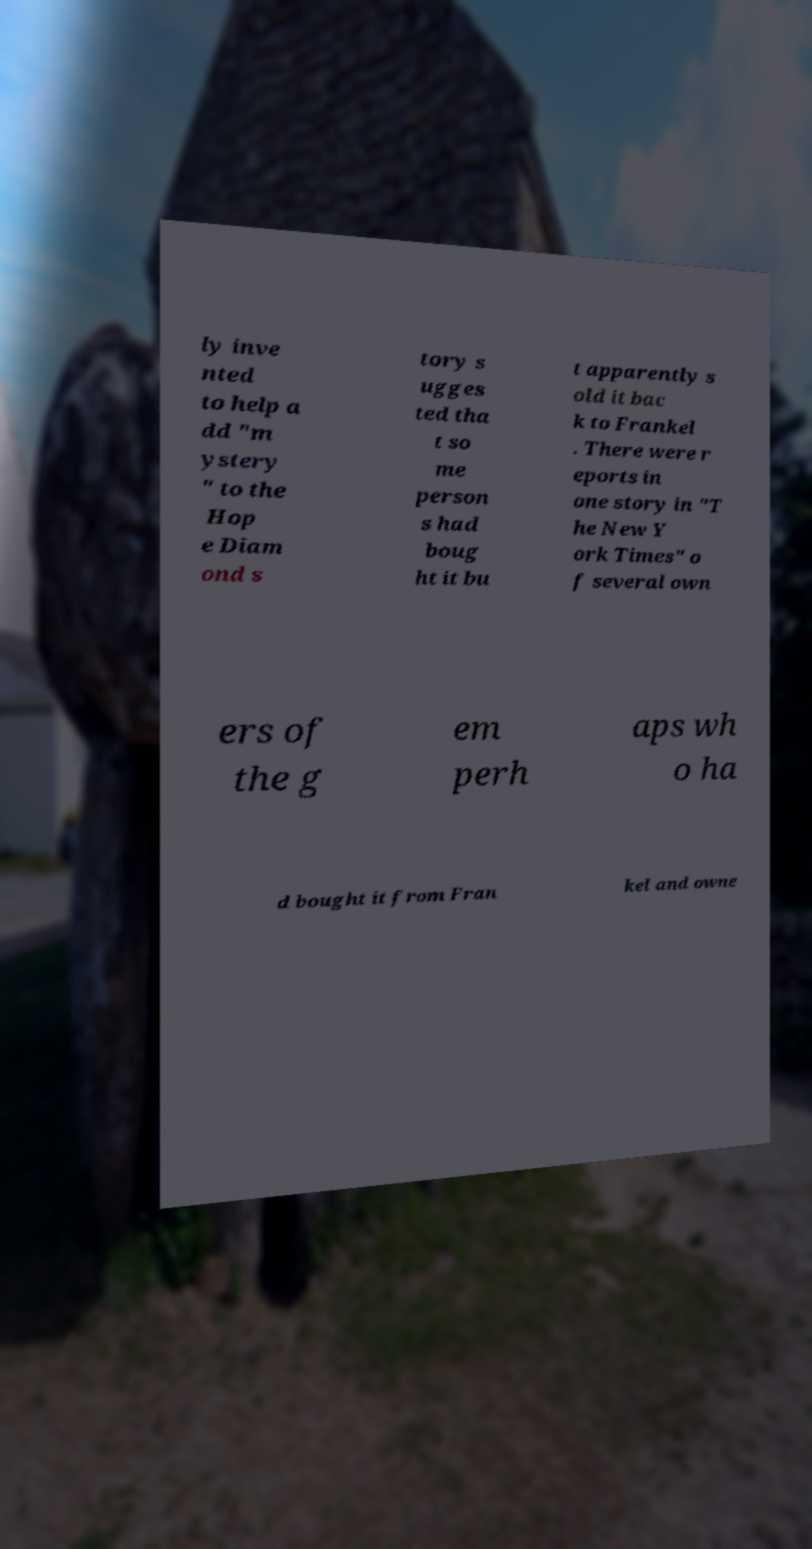There's text embedded in this image that I need extracted. Can you transcribe it verbatim? ly inve nted to help a dd "m ystery " to the Hop e Diam ond s tory s ugges ted tha t so me person s had boug ht it bu t apparently s old it bac k to Frankel . There were r eports in one story in "T he New Y ork Times" o f several own ers of the g em perh aps wh o ha d bought it from Fran kel and owne 